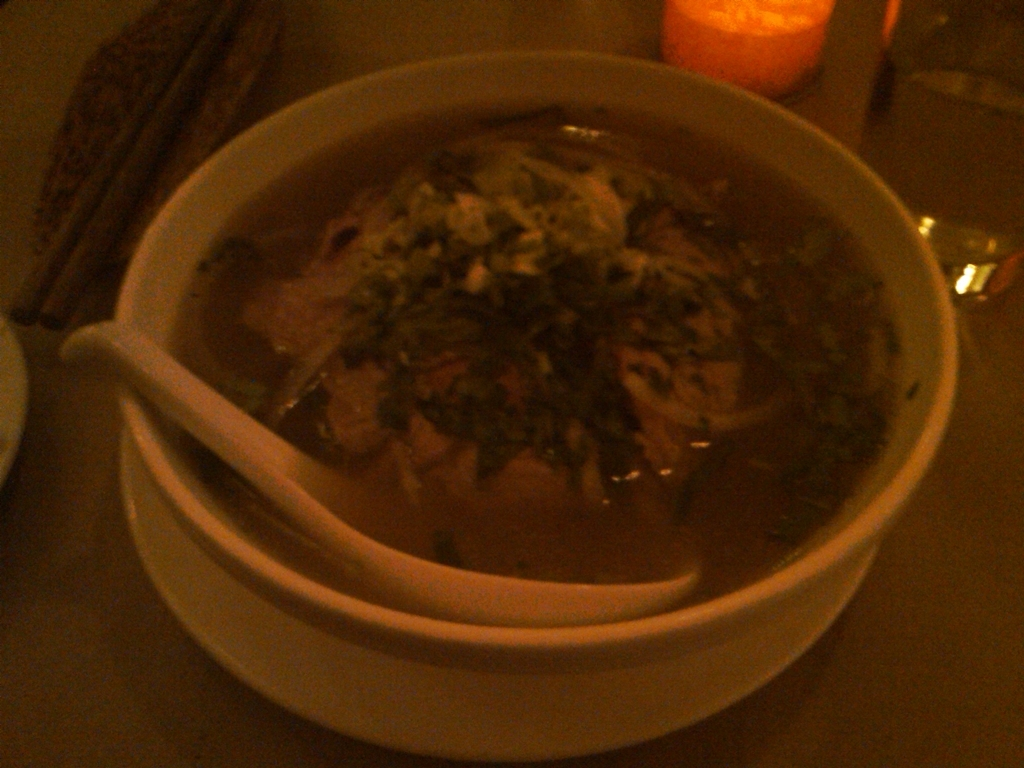Does the image have poor overall clarity? The image does appear to have poor overall clarity, likely due to low lighting conditions and potential camera shake or incorrect focus at the time the photo was taken. These factors have contributed to the lack of sharpness and detail in the image, which affects the visual quality. 